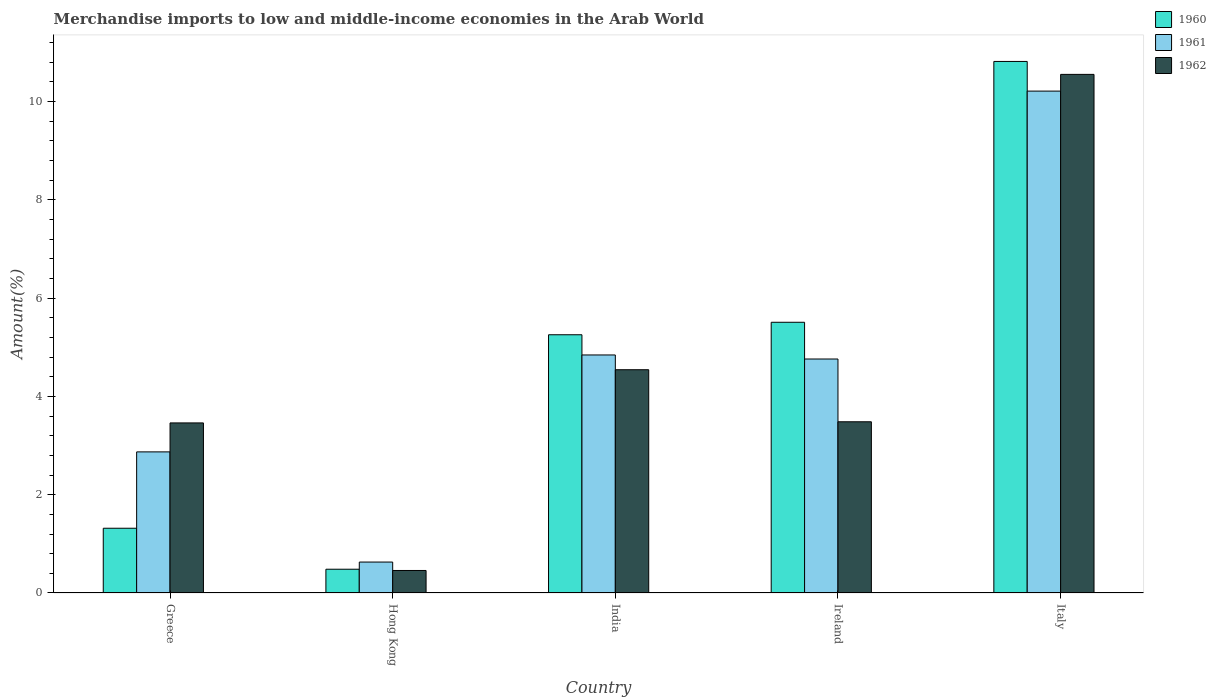How many groups of bars are there?
Provide a succinct answer. 5. Are the number of bars per tick equal to the number of legend labels?
Provide a short and direct response. Yes. How many bars are there on the 3rd tick from the left?
Offer a very short reply. 3. What is the percentage of amount earned from merchandise imports in 1961 in Ireland?
Your response must be concise. 4.76. Across all countries, what is the maximum percentage of amount earned from merchandise imports in 1962?
Keep it short and to the point. 10.55. Across all countries, what is the minimum percentage of amount earned from merchandise imports in 1961?
Offer a very short reply. 0.63. In which country was the percentage of amount earned from merchandise imports in 1962 minimum?
Provide a short and direct response. Hong Kong. What is the total percentage of amount earned from merchandise imports in 1961 in the graph?
Provide a short and direct response. 23.32. What is the difference between the percentage of amount earned from merchandise imports in 1961 in Greece and that in Italy?
Provide a short and direct response. -7.34. What is the difference between the percentage of amount earned from merchandise imports in 1962 in Ireland and the percentage of amount earned from merchandise imports in 1961 in Greece?
Provide a succinct answer. 0.61. What is the average percentage of amount earned from merchandise imports in 1960 per country?
Offer a terse response. 4.68. What is the difference between the percentage of amount earned from merchandise imports of/in 1960 and percentage of amount earned from merchandise imports of/in 1962 in Ireland?
Your response must be concise. 2.02. What is the ratio of the percentage of amount earned from merchandise imports in 1961 in India to that in Ireland?
Your answer should be compact. 1.02. Is the percentage of amount earned from merchandise imports in 1960 in Greece less than that in Italy?
Your answer should be compact. Yes. Is the difference between the percentage of amount earned from merchandise imports in 1960 in Greece and India greater than the difference between the percentage of amount earned from merchandise imports in 1962 in Greece and India?
Provide a succinct answer. No. What is the difference between the highest and the second highest percentage of amount earned from merchandise imports in 1960?
Offer a very short reply. 5.31. What is the difference between the highest and the lowest percentage of amount earned from merchandise imports in 1960?
Your response must be concise. 10.33. In how many countries, is the percentage of amount earned from merchandise imports in 1961 greater than the average percentage of amount earned from merchandise imports in 1961 taken over all countries?
Provide a short and direct response. 3. What does the 3rd bar from the right in Greece represents?
Keep it short and to the point. 1960. Is it the case that in every country, the sum of the percentage of amount earned from merchandise imports in 1961 and percentage of amount earned from merchandise imports in 1962 is greater than the percentage of amount earned from merchandise imports in 1960?
Make the answer very short. Yes. How many bars are there?
Make the answer very short. 15. Are all the bars in the graph horizontal?
Offer a very short reply. No. How many countries are there in the graph?
Offer a very short reply. 5. Does the graph contain any zero values?
Your answer should be compact. No. Does the graph contain grids?
Ensure brevity in your answer.  No. Where does the legend appear in the graph?
Your response must be concise. Top right. What is the title of the graph?
Make the answer very short. Merchandise imports to low and middle-income economies in the Arab World. What is the label or title of the Y-axis?
Provide a succinct answer. Amount(%). What is the Amount(%) of 1960 in Greece?
Your response must be concise. 1.32. What is the Amount(%) of 1961 in Greece?
Your answer should be very brief. 2.87. What is the Amount(%) of 1962 in Greece?
Offer a terse response. 3.46. What is the Amount(%) of 1960 in Hong Kong?
Your response must be concise. 0.48. What is the Amount(%) of 1961 in Hong Kong?
Provide a short and direct response. 0.63. What is the Amount(%) in 1962 in Hong Kong?
Ensure brevity in your answer.  0.46. What is the Amount(%) of 1960 in India?
Give a very brief answer. 5.25. What is the Amount(%) of 1961 in India?
Provide a short and direct response. 4.84. What is the Amount(%) of 1962 in India?
Ensure brevity in your answer.  4.54. What is the Amount(%) of 1960 in Ireland?
Provide a short and direct response. 5.51. What is the Amount(%) in 1961 in Ireland?
Give a very brief answer. 4.76. What is the Amount(%) in 1962 in Ireland?
Offer a terse response. 3.48. What is the Amount(%) in 1960 in Italy?
Provide a short and direct response. 10.82. What is the Amount(%) in 1961 in Italy?
Ensure brevity in your answer.  10.21. What is the Amount(%) in 1962 in Italy?
Make the answer very short. 10.55. Across all countries, what is the maximum Amount(%) of 1960?
Provide a short and direct response. 10.82. Across all countries, what is the maximum Amount(%) of 1961?
Offer a very short reply. 10.21. Across all countries, what is the maximum Amount(%) of 1962?
Offer a very short reply. 10.55. Across all countries, what is the minimum Amount(%) in 1960?
Provide a succinct answer. 0.48. Across all countries, what is the minimum Amount(%) in 1961?
Make the answer very short. 0.63. Across all countries, what is the minimum Amount(%) of 1962?
Offer a terse response. 0.46. What is the total Amount(%) in 1960 in the graph?
Your answer should be very brief. 23.38. What is the total Amount(%) of 1961 in the graph?
Offer a terse response. 23.32. What is the total Amount(%) of 1962 in the graph?
Offer a very short reply. 22.5. What is the difference between the Amount(%) in 1960 in Greece and that in Hong Kong?
Offer a terse response. 0.83. What is the difference between the Amount(%) of 1961 in Greece and that in Hong Kong?
Provide a succinct answer. 2.24. What is the difference between the Amount(%) in 1962 in Greece and that in Hong Kong?
Offer a terse response. 3. What is the difference between the Amount(%) in 1960 in Greece and that in India?
Your answer should be very brief. -3.94. What is the difference between the Amount(%) in 1961 in Greece and that in India?
Provide a succinct answer. -1.97. What is the difference between the Amount(%) in 1962 in Greece and that in India?
Provide a short and direct response. -1.08. What is the difference between the Amount(%) of 1960 in Greece and that in Ireland?
Provide a succinct answer. -4.19. What is the difference between the Amount(%) in 1961 in Greece and that in Ireland?
Offer a terse response. -1.89. What is the difference between the Amount(%) in 1962 in Greece and that in Ireland?
Keep it short and to the point. -0.02. What is the difference between the Amount(%) of 1960 in Greece and that in Italy?
Offer a terse response. -9.5. What is the difference between the Amount(%) of 1961 in Greece and that in Italy?
Your answer should be very brief. -7.34. What is the difference between the Amount(%) of 1962 in Greece and that in Italy?
Give a very brief answer. -7.09. What is the difference between the Amount(%) of 1960 in Hong Kong and that in India?
Provide a succinct answer. -4.77. What is the difference between the Amount(%) of 1961 in Hong Kong and that in India?
Ensure brevity in your answer.  -4.21. What is the difference between the Amount(%) in 1962 in Hong Kong and that in India?
Ensure brevity in your answer.  -4.08. What is the difference between the Amount(%) of 1960 in Hong Kong and that in Ireland?
Keep it short and to the point. -5.03. What is the difference between the Amount(%) in 1961 in Hong Kong and that in Ireland?
Keep it short and to the point. -4.13. What is the difference between the Amount(%) in 1962 in Hong Kong and that in Ireland?
Give a very brief answer. -3.03. What is the difference between the Amount(%) of 1960 in Hong Kong and that in Italy?
Ensure brevity in your answer.  -10.33. What is the difference between the Amount(%) in 1961 in Hong Kong and that in Italy?
Your response must be concise. -9.58. What is the difference between the Amount(%) of 1962 in Hong Kong and that in Italy?
Give a very brief answer. -10.1. What is the difference between the Amount(%) in 1960 in India and that in Ireland?
Keep it short and to the point. -0.25. What is the difference between the Amount(%) of 1961 in India and that in Ireland?
Your answer should be very brief. 0.08. What is the difference between the Amount(%) in 1962 in India and that in Ireland?
Offer a very short reply. 1.06. What is the difference between the Amount(%) of 1960 in India and that in Italy?
Provide a short and direct response. -5.56. What is the difference between the Amount(%) in 1961 in India and that in Italy?
Offer a very short reply. -5.37. What is the difference between the Amount(%) of 1962 in India and that in Italy?
Give a very brief answer. -6.01. What is the difference between the Amount(%) in 1960 in Ireland and that in Italy?
Your answer should be very brief. -5.31. What is the difference between the Amount(%) in 1961 in Ireland and that in Italy?
Provide a succinct answer. -5.45. What is the difference between the Amount(%) of 1962 in Ireland and that in Italy?
Make the answer very short. -7.07. What is the difference between the Amount(%) of 1960 in Greece and the Amount(%) of 1961 in Hong Kong?
Your response must be concise. 0.69. What is the difference between the Amount(%) of 1960 in Greece and the Amount(%) of 1962 in Hong Kong?
Your answer should be compact. 0.86. What is the difference between the Amount(%) in 1961 in Greece and the Amount(%) in 1962 in Hong Kong?
Your answer should be very brief. 2.41. What is the difference between the Amount(%) in 1960 in Greece and the Amount(%) in 1961 in India?
Your answer should be very brief. -3.53. What is the difference between the Amount(%) of 1960 in Greece and the Amount(%) of 1962 in India?
Provide a short and direct response. -3.23. What is the difference between the Amount(%) of 1961 in Greece and the Amount(%) of 1962 in India?
Ensure brevity in your answer.  -1.67. What is the difference between the Amount(%) in 1960 in Greece and the Amount(%) in 1961 in Ireland?
Give a very brief answer. -3.44. What is the difference between the Amount(%) in 1960 in Greece and the Amount(%) in 1962 in Ireland?
Your answer should be compact. -2.17. What is the difference between the Amount(%) in 1961 in Greece and the Amount(%) in 1962 in Ireland?
Your response must be concise. -0.61. What is the difference between the Amount(%) of 1960 in Greece and the Amount(%) of 1961 in Italy?
Your answer should be very brief. -8.9. What is the difference between the Amount(%) in 1960 in Greece and the Amount(%) in 1962 in Italy?
Offer a terse response. -9.24. What is the difference between the Amount(%) in 1961 in Greece and the Amount(%) in 1962 in Italy?
Keep it short and to the point. -7.68. What is the difference between the Amount(%) in 1960 in Hong Kong and the Amount(%) in 1961 in India?
Keep it short and to the point. -4.36. What is the difference between the Amount(%) in 1960 in Hong Kong and the Amount(%) in 1962 in India?
Your answer should be very brief. -4.06. What is the difference between the Amount(%) of 1961 in Hong Kong and the Amount(%) of 1962 in India?
Your answer should be very brief. -3.91. What is the difference between the Amount(%) of 1960 in Hong Kong and the Amount(%) of 1961 in Ireland?
Your answer should be very brief. -4.28. What is the difference between the Amount(%) of 1960 in Hong Kong and the Amount(%) of 1962 in Ireland?
Keep it short and to the point. -3. What is the difference between the Amount(%) in 1961 in Hong Kong and the Amount(%) in 1962 in Ireland?
Give a very brief answer. -2.85. What is the difference between the Amount(%) in 1960 in Hong Kong and the Amount(%) in 1961 in Italy?
Provide a succinct answer. -9.73. What is the difference between the Amount(%) in 1960 in Hong Kong and the Amount(%) in 1962 in Italy?
Ensure brevity in your answer.  -10.07. What is the difference between the Amount(%) of 1961 in Hong Kong and the Amount(%) of 1962 in Italy?
Keep it short and to the point. -9.92. What is the difference between the Amount(%) of 1960 in India and the Amount(%) of 1961 in Ireland?
Keep it short and to the point. 0.49. What is the difference between the Amount(%) of 1960 in India and the Amount(%) of 1962 in Ireland?
Ensure brevity in your answer.  1.77. What is the difference between the Amount(%) of 1961 in India and the Amount(%) of 1962 in Ireland?
Your response must be concise. 1.36. What is the difference between the Amount(%) in 1960 in India and the Amount(%) in 1961 in Italy?
Ensure brevity in your answer.  -4.96. What is the difference between the Amount(%) in 1960 in India and the Amount(%) in 1962 in Italy?
Offer a very short reply. -5.3. What is the difference between the Amount(%) of 1961 in India and the Amount(%) of 1962 in Italy?
Give a very brief answer. -5.71. What is the difference between the Amount(%) in 1960 in Ireland and the Amount(%) in 1961 in Italy?
Your response must be concise. -4.7. What is the difference between the Amount(%) in 1960 in Ireland and the Amount(%) in 1962 in Italy?
Offer a terse response. -5.04. What is the difference between the Amount(%) in 1961 in Ireland and the Amount(%) in 1962 in Italy?
Give a very brief answer. -5.79. What is the average Amount(%) in 1960 per country?
Provide a succinct answer. 4.68. What is the average Amount(%) of 1961 per country?
Keep it short and to the point. 4.66. What is the average Amount(%) in 1962 per country?
Give a very brief answer. 4.5. What is the difference between the Amount(%) of 1960 and Amount(%) of 1961 in Greece?
Provide a short and direct response. -1.55. What is the difference between the Amount(%) in 1960 and Amount(%) in 1962 in Greece?
Your response must be concise. -2.14. What is the difference between the Amount(%) in 1961 and Amount(%) in 1962 in Greece?
Offer a very short reply. -0.59. What is the difference between the Amount(%) of 1960 and Amount(%) of 1961 in Hong Kong?
Your answer should be compact. -0.15. What is the difference between the Amount(%) in 1960 and Amount(%) in 1962 in Hong Kong?
Make the answer very short. 0.03. What is the difference between the Amount(%) of 1961 and Amount(%) of 1962 in Hong Kong?
Give a very brief answer. 0.17. What is the difference between the Amount(%) of 1960 and Amount(%) of 1961 in India?
Provide a succinct answer. 0.41. What is the difference between the Amount(%) of 1960 and Amount(%) of 1962 in India?
Your response must be concise. 0.71. What is the difference between the Amount(%) in 1961 and Amount(%) in 1962 in India?
Offer a very short reply. 0.3. What is the difference between the Amount(%) in 1960 and Amount(%) in 1961 in Ireland?
Make the answer very short. 0.75. What is the difference between the Amount(%) in 1960 and Amount(%) in 1962 in Ireland?
Your answer should be very brief. 2.02. What is the difference between the Amount(%) in 1961 and Amount(%) in 1962 in Ireland?
Provide a short and direct response. 1.28. What is the difference between the Amount(%) in 1960 and Amount(%) in 1961 in Italy?
Provide a short and direct response. 0.6. What is the difference between the Amount(%) in 1960 and Amount(%) in 1962 in Italy?
Provide a succinct answer. 0.26. What is the difference between the Amount(%) of 1961 and Amount(%) of 1962 in Italy?
Offer a very short reply. -0.34. What is the ratio of the Amount(%) of 1960 in Greece to that in Hong Kong?
Offer a terse response. 2.72. What is the ratio of the Amount(%) of 1961 in Greece to that in Hong Kong?
Make the answer very short. 4.56. What is the ratio of the Amount(%) of 1962 in Greece to that in Hong Kong?
Keep it short and to the point. 7.55. What is the ratio of the Amount(%) in 1960 in Greece to that in India?
Provide a short and direct response. 0.25. What is the ratio of the Amount(%) in 1961 in Greece to that in India?
Offer a terse response. 0.59. What is the ratio of the Amount(%) of 1962 in Greece to that in India?
Your response must be concise. 0.76. What is the ratio of the Amount(%) of 1960 in Greece to that in Ireland?
Make the answer very short. 0.24. What is the ratio of the Amount(%) of 1961 in Greece to that in Ireland?
Provide a short and direct response. 0.6. What is the ratio of the Amount(%) in 1960 in Greece to that in Italy?
Your answer should be compact. 0.12. What is the ratio of the Amount(%) of 1961 in Greece to that in Italy?
Your answer should be very brief. 0.28. What is the ratio of the Amount(%) of 1962 in Greece to that in Italy?
Offer a terse response. 0.33. What is the ratio of the Amount(%) of 1960 in Hong Kong to that in India?
Provide a short and direct response. 0.09. What is the ratio of the Amount(%) in 1961 in Hong Kong to that in India?
Your answer should be very brief. 0.13. What is the ratio of the Amount(%) of 1962 in Hong Kong to that in India?
Make the answer very short. 0.1. What is the ratio of the Amount(%) in 1960 in Hong Kong to that in Ireland?
Your answer should be very brief. 0.09. What is the ratio of the Amount(%) of 1961 in Hong Kong to that in Ireland?
Your answer should be very brief. 0.13. What is the ratio of the Amount(%) of 1962 in Hong Kong to that in Ireland?
Your answer should be compact. 0.13. What is the ratio of the Amount(%) in 1960 in Hong Kong to that in Italy?
Your response must be concise. 0.04. What is the ratio of the Amount(%) in 1961 in Hong Kong to that in Italy?
Provide a succinct answer. 0.06. What is the ratio of the Amount(%) of 1962 in Hong Kong to that in Italy?
Keep it short and to the point. 0.04. What is the ratio of the Amount(%) of 1960 in India to that in Ireland?
Provide a succinct answer. 0.95. What is the ratio of the Amount(%) of 1961 in India to that in Ireland?
Your response must be concise. 1.02. What is the ratio of the Amount(%) of 1962 in India to that in Ireland?
Ensure brevity in your answer.  1.3. What is the ratio of the Amount(%) in 1960 in India to that in Italy?
Offer a terse response. 0.49. What is the ratio of the Amount(%) of 1961 in India to that in Italy?
Offer a very short reply. 0.47. What is the ratio of the Amount(%) in 1962 in India to that in Italy?
Offer a very short reply. 0.43. What is the ratio of the Amount(%) in 1960 in Ireland to that in Italy?
Your response must be concise. 0.51. What is the ratio of the Amount(%) of 1961 in Ireland to that in Italy?
Make the answer very short. 0.47. What is the ratio of the Amount(%) of 1962 in Ireland to that in Italy?
Provide a short and direct response. 0.33. What is the difference between the highest and the second highest Amount(%) of 1960?
Offer a terse response. 5.31. What is the difference between the highest and the second highest Amount(%) in 1961?
Provide a succinct answer. 5.37. What is the difference between the highest and the second highest Amount(%) of 1962?
Ensure brevity in your answer.  6.01. What is the difference between the highest and the lowest Amount(%) in 1960?
Keep it short and to the point. 10.33. What is the difference between the highest and the lowest Amount(%) in 1961?
Keep it short and to the point. 9.58. What is the difference between the highest and the lowest Amount(%) of 1962?
Give a very brief answer. 10.1. 